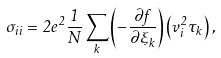<formula> <loc_0><loc_0><loc_500><loc_500>\sigma _ { i i } = 2 e ^ { 2 } \frac { 1 } { N } \sum _ { k } \left ( - \frac { \partial f } { \partial \xi _ { k } } \right ) \left ( v ^ { 2 } _ { i } \tau _ { k } \right ) ,</formula> 